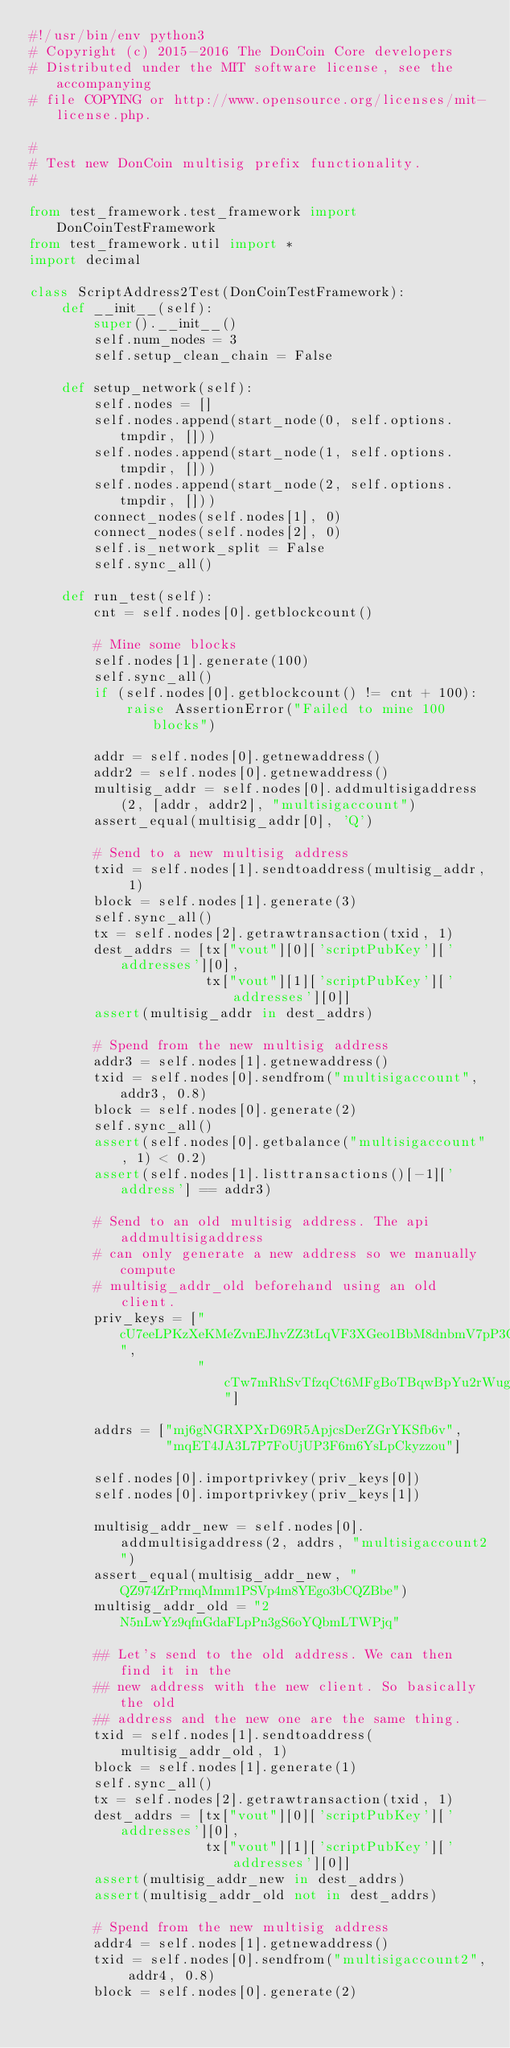Convert code to text. <code><loc_0><loc_0><loc_500><loc_500><_Python_>#!/usr/bin/env python3
# Copyright (c) 2015-2016 The DonCoin Core developers
# Distributed under the MIT software license, see the accompanying
# file COPYING or http://www.opensource.org/licenses/mit-license.php.

#
# Test new DonCoin multisig prefix functionality.
#

from test_framework.test_framework import DonCoinTestFramework
from test_framework.util import *
import decimal

class ScriptAddress2Test(DonCoinTestFramework):
    def __init__(self):
        super().__init__()
        self.num_nodes = 3
        self.setup_clean_chain = False

    def setup_network(self):
        self.nodes = []
        self.nodes.append(start_node(0, self.options.tmpdir, []))
        self.nodes.append(start_node(1, self.options.tmpdir, []))
        self.nodes.append(start_node(2, self.options.tmpdir, []))
        connect_nodes(self.nodes[1], 0)
        connect_nodes(self.nodes[2], 0)
        self.is_network_split = False
        self.sync_all()

    def run_test(self):
        cnt = self.nodes[0].getblockcount()

        # Mine some blocks
        self.nodes[1].generate(100)
        self.sync_all()
        if (self.nodes[0].getblockcount() != cnt + 100):
            raise AssertionError("Failed to mine 100 blocks")

        addr = self.nodes[0].getnewaddress()
        addr2 = self.nodes[0].getnewaddress()
        multisig_addr = self.nodes[0].addmultisigaddress(2, [addr, addr2], "multisigaccount")
        assert_equal(multisig_addr[0], 'Q')

        # Send to a new multisig address
        txid = self.nodes[1].sendtoaddress(multisig_addr, 1)
        block = self.nodes[1].generate(3)
        self.sync_all()
        tx = self.nodes[2].getrawtransaction(txid, 1)
        dest_addrs = [tx["vout"][0]['scriptPubKey']['addresses'][0],
                      tx["vout"][1]['scriptPubKey']['addresses'][0]]
        assert(multisig_addr in dest_addrs)

        # Spend from the new multisig address
        addr3 = self.nodes[1].getnewaddress()
        txid = self.nodes[0].sendfrom("multisigaccount", addr3, 0.8)
        block = self.nodes[0].generate(2)
        self.sync_all()
        assert(self.nodes[0].getbalance("multisigaccount", 1) < 0.2)
        assert(self.nodes[1].listtransactions()[-1]['address'] == addr3)

        # Send to an old multisig address. The api addmultisigaddress
        # can only generate a new address so we manually compute
        # multisig_addr_old beforehand using an old client.
        priv_keys = ["cU7eeLPKzXeKMeZvnEJhvZZ3tLqVF3XGeo1BbM8dnbmV7pP3Qg89",
                     "cTw7mRhSvTfzqCt6MFgBoTBqwBpYu2rWugisXcwjv4cAASh3iqPt"]

        addrs = ["mj6gNGRXPXrD69R5ApjcsDerZGrYKSfb6v",
                 "mqET4JA3L7P7FoUjUP3F6m6YsLpCkyzzou"]

        self.nodes[0].importprivkey(priv_keys[0])
        self.nodes[0].importprivkey(priv_keys[1])

        multisig_addr_new = self.nodes[0].addmultisigaddress(2, addrs, "multisigaccount2")
        assert_equal(multisig_addr_new, "QZ974ZrPrmqMmm1PSVp4m8YEgo3bCQZBbe")
        multisig_addr_old = "2N5nLwYz9qfnGdaFLpPn3gS6oYQbmLTWPjq"
        
        ## Let's send to the old address. We can then find it in the
        ## new address with the new client. So basically the old
        ## address and the new one are the same thing.
        txid = self.nodes[1].sendtoaddress(multisig_addr_old, 1)
        block = self.nodes[1].generate(1)
        self.sync_all()
        tx = self.nodes[2].getrawtransaction(txid, 1)
        dest_addrs = [tx["vout"][0]['scriptPubKey']['addresses'][0],
                      tx["vout"][1]['scriptPubKey']['addresses'][0]]
        assert(multisig_addr_new in dest_addrs)
        assert(multisig_addr_old not in dest_addrs)

        # Spend from the new multisig address
        addr4 = self.nodes[1].getnewaddress()
        txid = self.nodes[0].sendfrom("multisigaccount2", addr4, 0.8)
        block = self.nodes[0].generate(2)</code> 